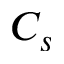<formula> <loc_0><loc_0><loc_500><loc_500>C _ { s }</formula> 